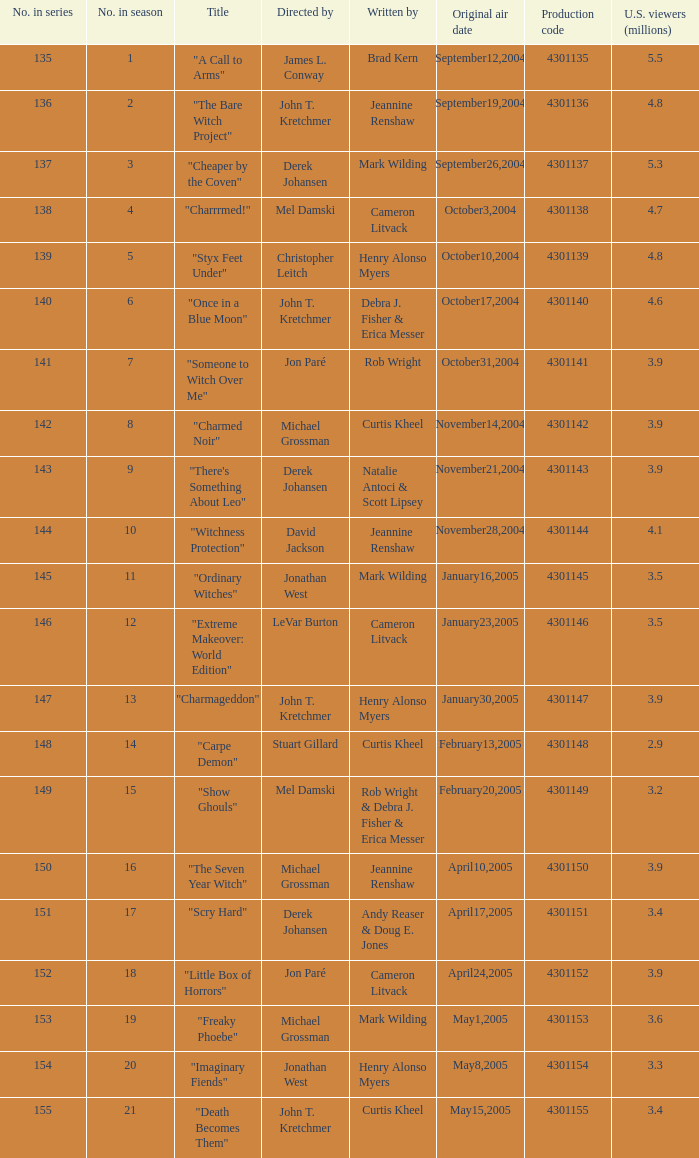In season number 3,  who were the writers? Mark Wilding. 